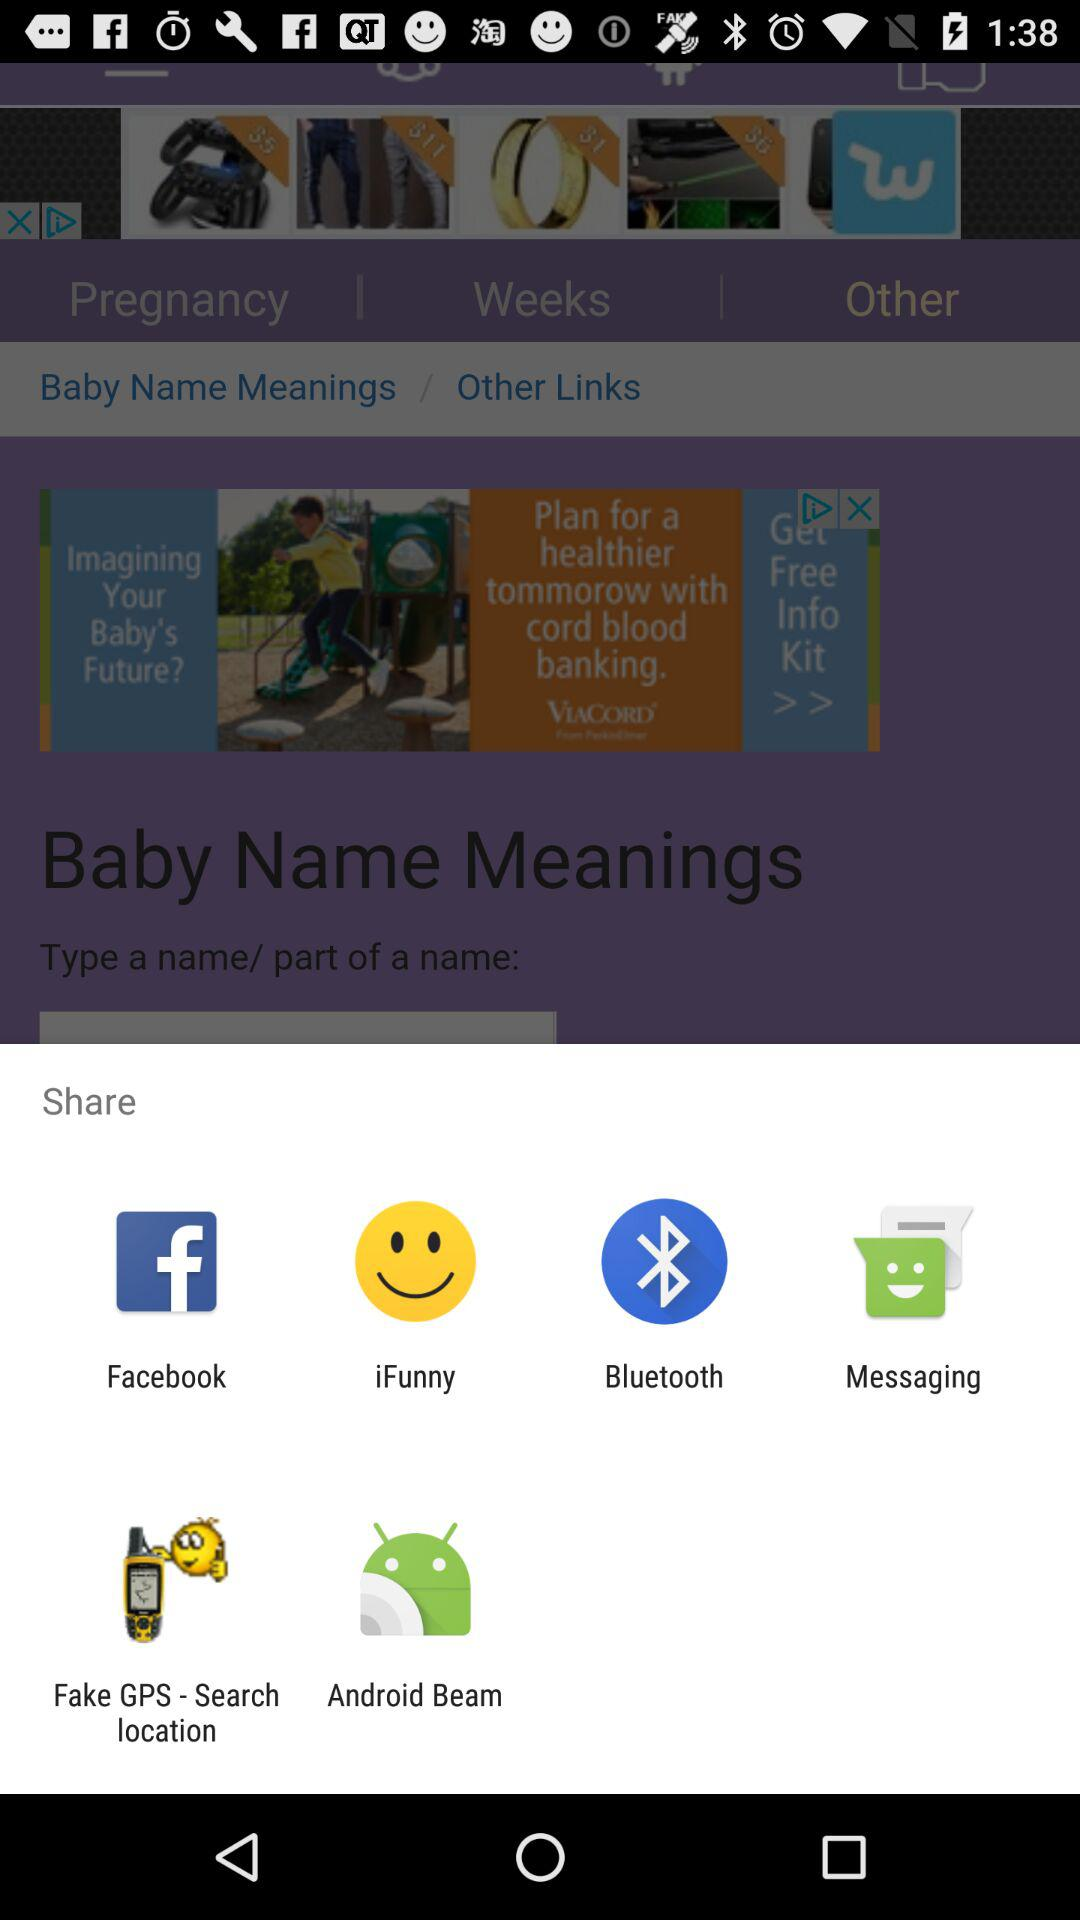Which applications can be used for sharing? The applications that can be used for sharing are "Facebook", "iFunny", "Bluetooth", "Messaging", "Fake GPS - Search location" and "Android Beam". 